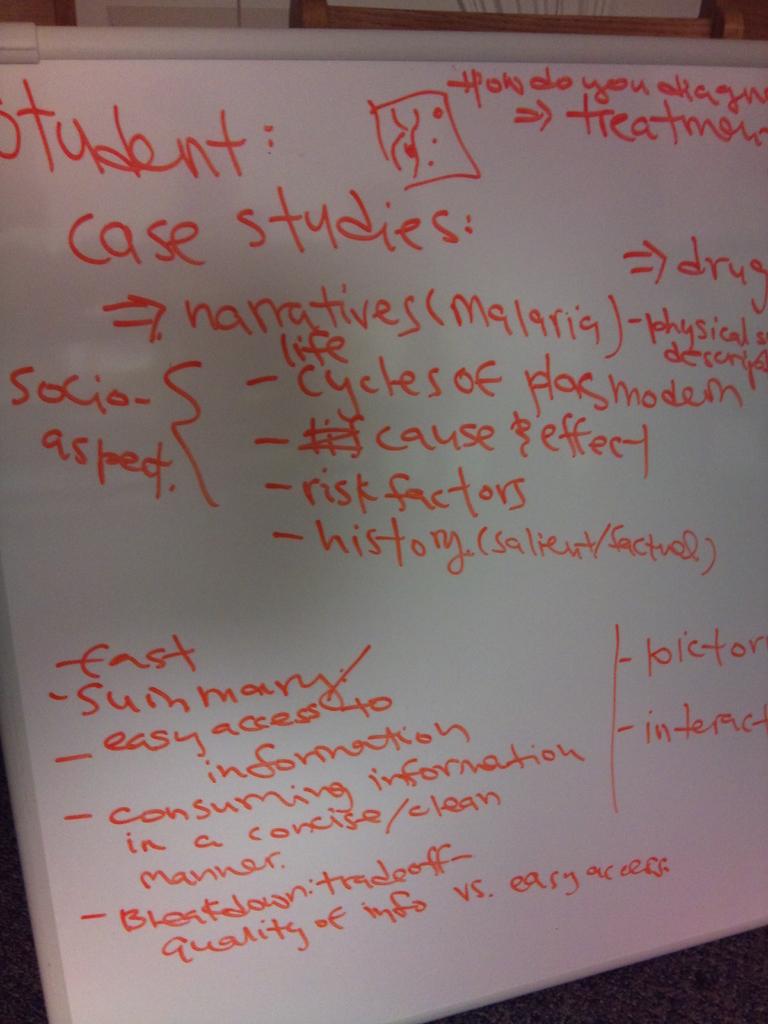What are the social aspects on the board?
Keep it short and to the point. Unanswerable. What is the first topic on the top left?
Give a very brief answer. Student case studies. 